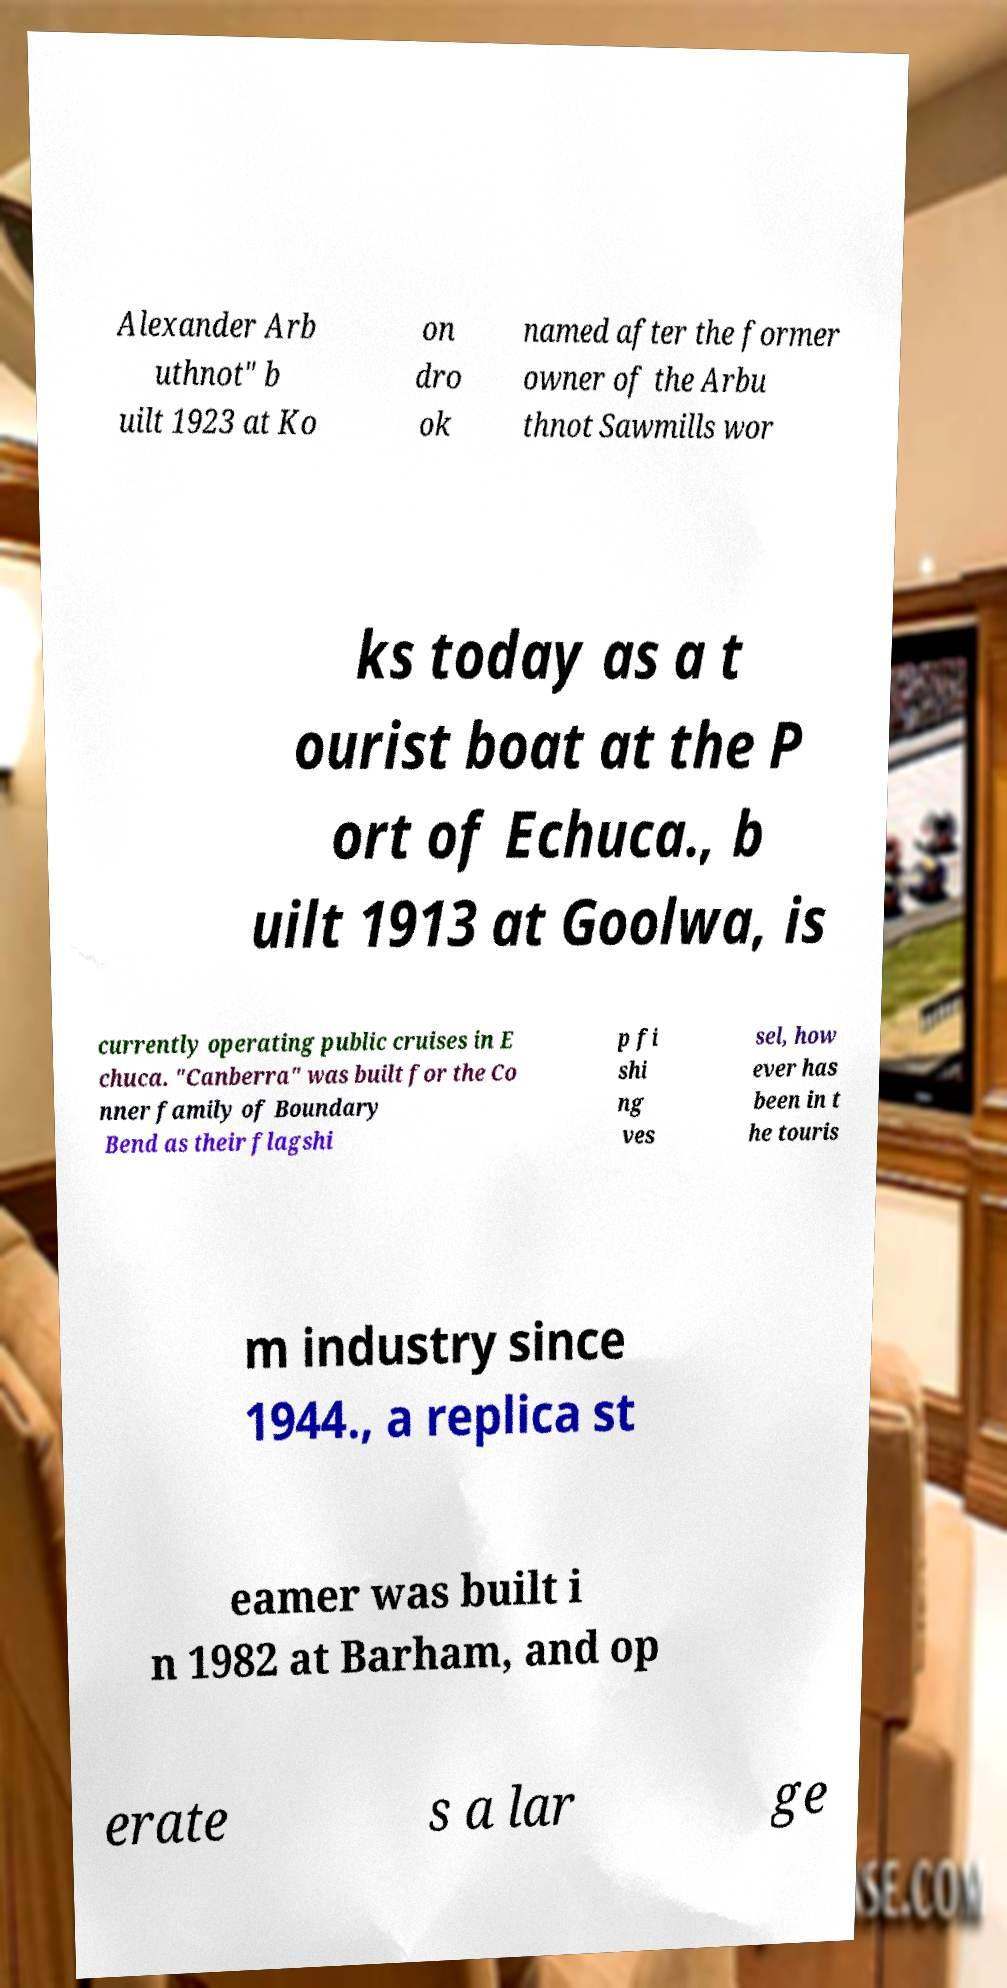There's text embedded in this image that I need extracted. Can you transcribe it verbatim? Alexander Arb uthnot" b uilt 1923 at Ko on dro ok named after the former owner of the Arbu thnot Sawmills wor ks today as a t ourist boat at the P ort of Echuca., b uilt 1913 at Goolwa, is currently operating public cruises in E chuca. "Canberra" was built for the Co nner family of Boundary Bend as their flagshi p fi shi ng ves sel, how ever has been in t he touris m industry since 1944., a replica st eamer was built i n 1982 at Barham, and op erate s a lar ge 